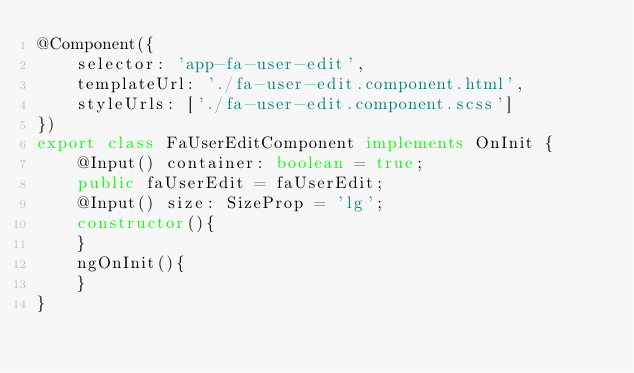Convert code to text. <code><loc_0><loc_0><loc_500><loc_500><_TypeScript_>@Component({
	selector: 'app-fa-user-edit',
	templateUrl: './fa-user-edit.component.html',
	styleUrls: ['./fa-user-edit.component.scss']
})
export class FaUserEditComponent implements OnInit {
	@Input() container: boolean = true;
	public faUserEdit = faUserEdit;
	@Input() size: SizeProp = 'lg';
	constructor(){
	}
	ngOnInit(){
	}
}
</code> 